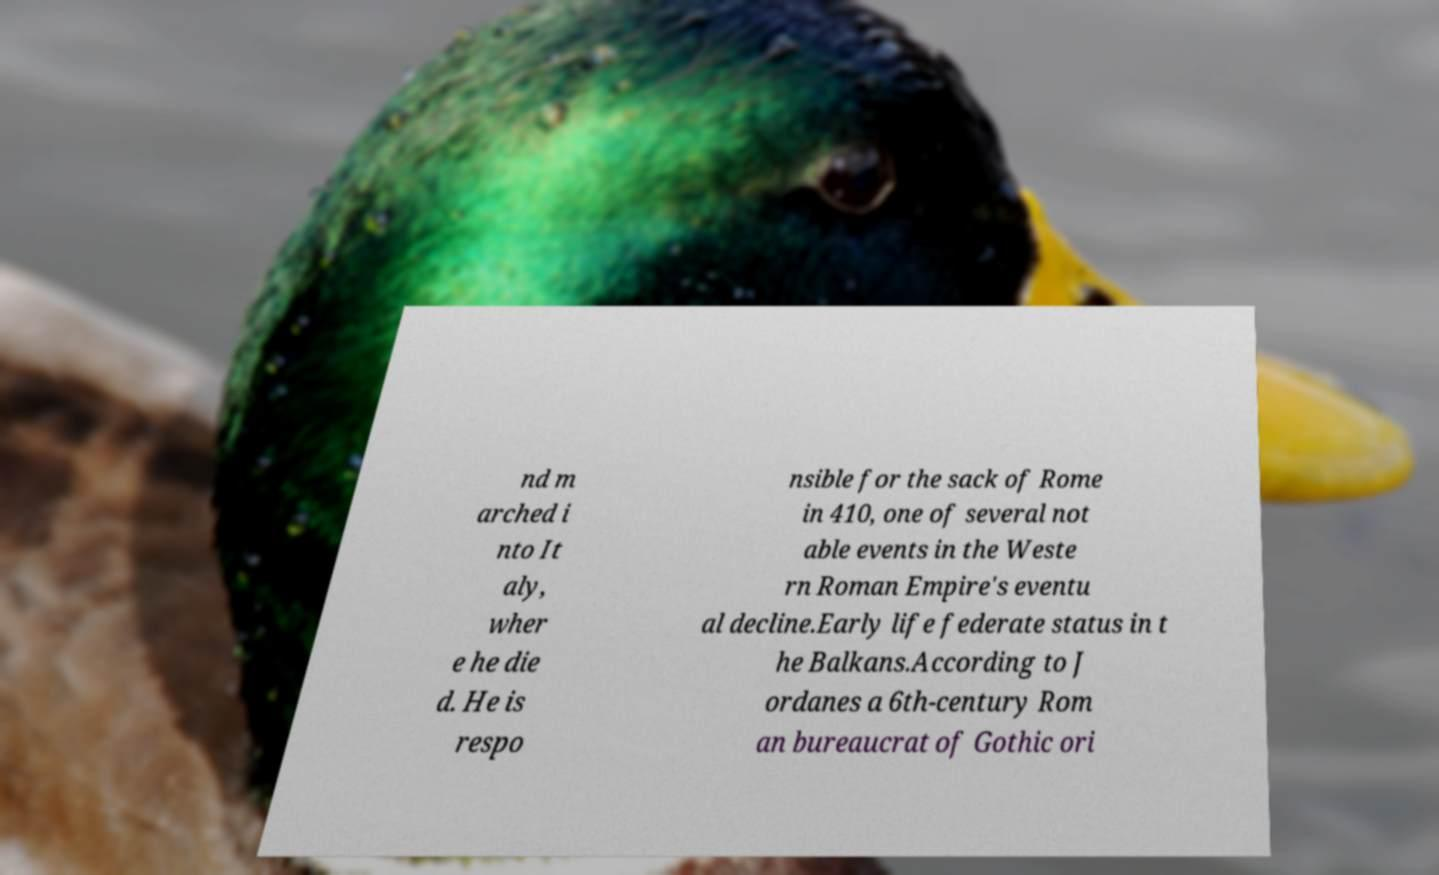I need the written content from this picture converted into text. Can you do that? nd m arched i nto It aly, wher e he die d. He is respo nsible for the sack of Rome in 410, one of several not able events in the Weste rn Roman Empire's eventu al decline.Early life federate status in t he Balkans.According to J ordanes a 6th-century Rom an bureaucrat of Gothic ori 